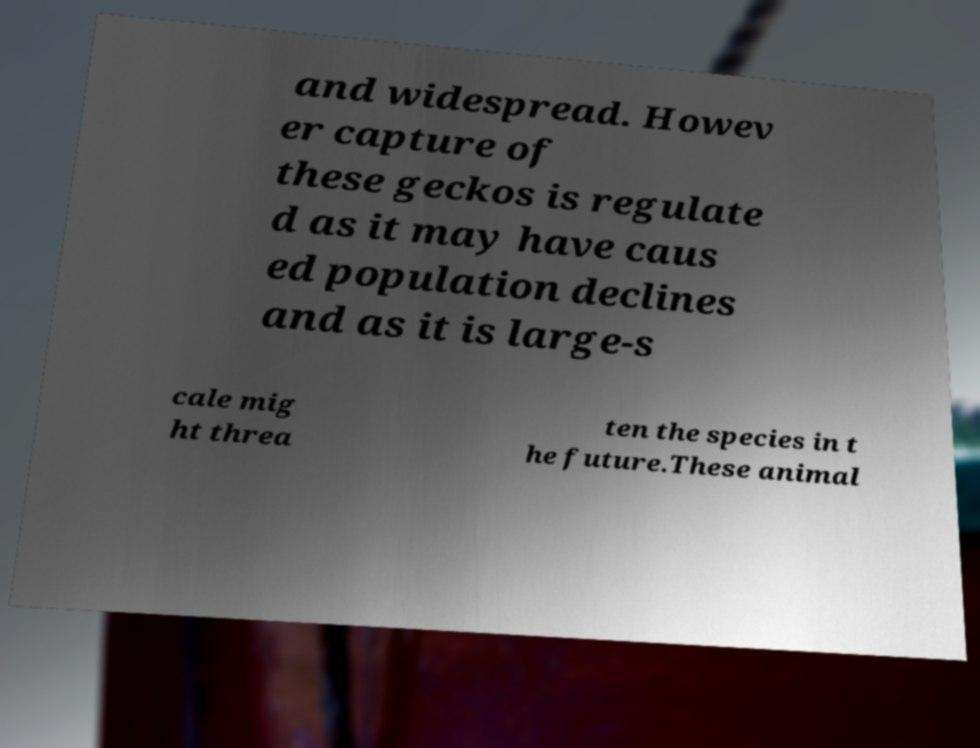Please read and relay the text visible in this image. What does it say? and widespread. Howev er capture of these geckos is regulate d as it may have caus ed population declines and as it is large-s cale mig ht threa ten the species in t he future.These animal 